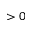<formula> <loc_0><loc_0><loc_500><loc_500>> 0</formula> 